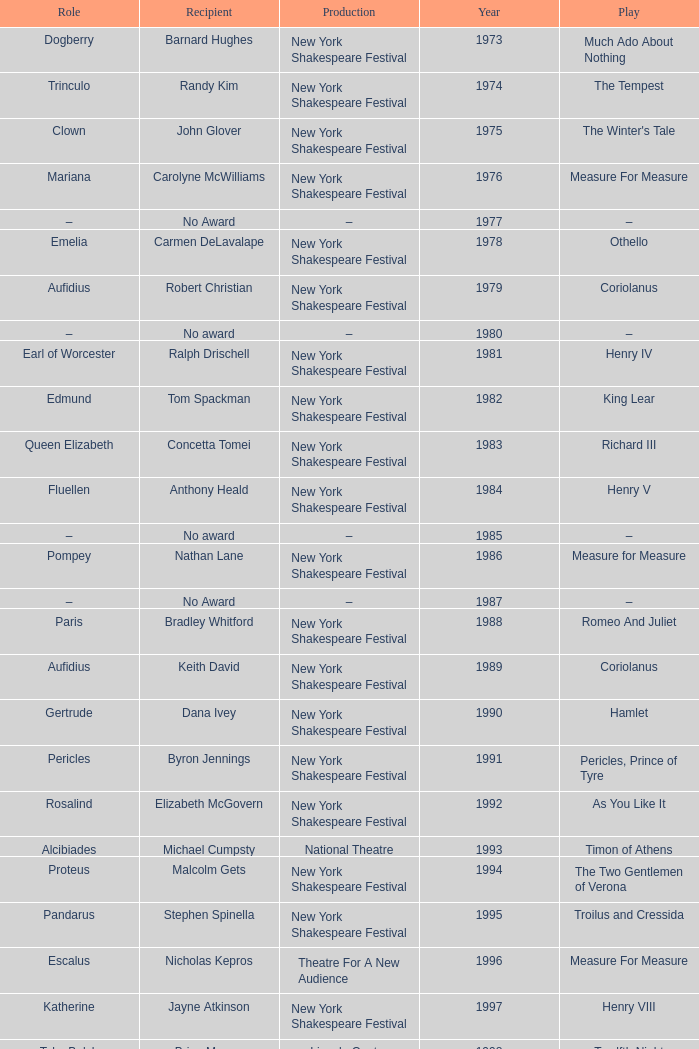Name the average year for much ado about nothing and recipient of ray virta 2002.0. 